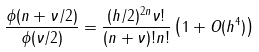Convert formula to latex. <formula><loc_0><loc_0><loc_500><loc_500>\frac { \phi ( n + \nu / 2 ) } { \phi ( \nu / 2 ) } = \frac { ( h / 2 ) ^ { 2 n } \nu ! } { ( n + \nu ) ! n ! } \left ( 1 + O ( h ^ { 4 } ) \right )</formula> 